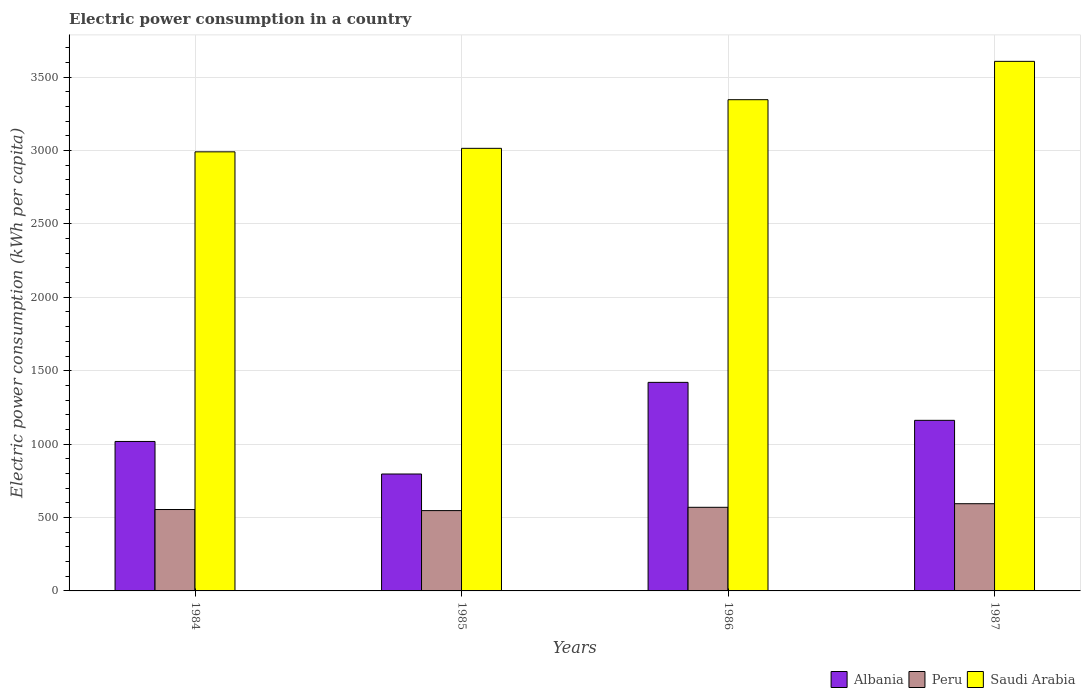How many different coloured bars are there?
Offer a very short reply. 3. Are the number of bars per tick equal to the number of legend labels?
Your response must be concise. Yes. Are the number of bars on each tick of the X-axis equal?
Give a very brief answer. Yes. How many bars are there on the 1st tick from the left?
Provide a succinct answer. 3. What is the label of the 3rd group of bars from the left?
Give a very brief answer. 1986. What is the electric power consumption in in Albania in 1987?
Ensure brevity in your answer.  1161.95. Across all years, what is the maximum electric power consumption in in Saudi Arabia?
Your answer should be compact. 3607.28. Across all years, what is the minimum electric power consumption in in Albania?
Give a very brief answer. 796.35. In which year was the electric power consumption in in Albania maximum?
Your answer should be very brief. 1986. What is the total electric power consumption in in Peru in the graph?
Your answer should be very brief. 2265.2. What is the difference between the electric power consumption in in Albania in 1985 and that in 1987?
Provide a short and direct response. -365.6. What is the difference between the electric power consumption in in Albania in 1986 and the electric power consumption in in Saudi Arabia in 1985?
Provide a succinct answer. -1594.14. What is the average electric power consumption in in Saudi Arabia per year?
Your answer should be compact. 3239.76. In the year 1986, what is the difference between the electric power consumption in in Albania and electric power consumption in in Peru?
Keep it short and to the point. 851.01. What is the ratio of the electric power consumption in in Peru in 1984 to that in 1985?
Keep it short and to the point. 1.01. Is the electric power consumption in in Peru in 1984 less than that in 1985?
Give a very brief answer. No. What is the difference between the highest and the second highest electric power consumption in in Albania?
Your response must be concise. 258.66. What is the difference between the highest and the lowest electric power consumption in in Peru?
Your response must be concise. 46.98. What does the 2nd bar from the left in 1984 represents?
Offer a terse response. Peru. What does the 1st bar from the right in 1986 represents?
Offer a very short reply. Saudi Arabia. Are all the bars in the graph horizontal?
Ensure brevity in your answer.  No. Are the values on the major ticks of Y-axis written in scientific E-notation?
Offer a terse response. No. Does the graph contain grids?
Offer a terse response. Yes. Where does the legend appear in the graph?
Your answer should be compact. Bottom right. What is the title of the graph?
Offer a very short reply. Electric power consumption in a country. Does "Monaco" appear as one of the legend labels in the graph?
Give a very brief answer. No. What is the label or title of the X-axis?
Provide a succinct answer. Years. What is the label or title of the Y-axis?
Provide a succinct answer. Electric power consumption (kWh per capita). What is the Electric power consumption (kWh per capita) in Albania in 1984?
Provide a succinct answer. 1018.1. What is the Electric power consumption (kWh per capita) of Peru in 1984?
Provide a short and direct response. 554.41. What is the Electric power consumption (kWh per capita) in Saudi Arabia in 1984?
Provide a short and direct response. 2990.91. What is the Electric power consumption (kWh per capita) in Albania in 1985?
Keep it short and to the point. 796.35. What is the Electric power consumption (kWh per capita) of Peru in 1985?
Ensure brevity in your answer.  547.1. What is the Electric power consumption (kWh per capita) of Saudi Arabia in 1985?
Ensure brevity in your answer.  3014.76. What is the Electric power consumption (kWh per capita) in Albania in 1986?
Your answer should be compact. 1420.61. What is the Electric power consumption (kWh per capita) of Peru in 1986?
Give a very brief answer. 569.61. What is the Electric power consumption (kWh per capita) of Saudi Arabia in 1986?
Offer a terse response. 3346.11. What is the Electric power consumption (kWh per capita) in Albania in 1987?
Give a very brief answer. 1161.95. What is the Electric power consumption (kWh per capita) of Peru in 1987?
Keep it short and to the point. 594.08. What is the Electric power consumption (kWh per capita) in Saudi Arabia in 1987?
Ensure brevity in your answer.  3607.28. Across all years, what is the maximum Electric power consumption (kWh per capita) of Albania?
Give a very brief answer. 1420.61. Across all years, what is the maximum Electric power consumption (kWh per capita) of Peru?
Make the answer very short. 594.08. Across all years, what is the maximum Electric power consumption (kWh per capita) in Saudi Arabia?
Give a very brief answer. 3607.28. Across all years, what is the minimum Electric power consumption (kWh per capita) in Albania?
Ensure brevity in your answer.  796.35. Across all years, what is the minimum Electric power consumption (kWh per capita) in Peru?
Your answer should be very brief. 547.1. Across all years, what is the minimum Electric power consumption (kWh per capita) in Saudi Arabia?
Make the answer very short. 2990.91. What is the total Electric power consumption (kWh per capita) in Albania in the graph?
Make the answer very short. 4397.02. What is the total Electric power consumption (kWh per capita) of Peru in the graph?
Offer a terse response. 2265.2. What is the total Electric power consumption (kWh per capita) in Saudi Arabia in the graph?
Keep it short and to the point. 1.30e+04. What is the difference between the Electric power consumption (kWh per capita) in Albania in 1984 and that in 1985?
Offer a terse response. 221.75. What is the difference between the Electric power consumption (kWh per capita) in Peru in 1984 and that in 1985?
Offer a terse response. 7.31. What is the difference between the Electric power consumption (kWh per capita) of Saudi Arabia in 1984 and that in 1985?
Keep it short and to the point. -23.85. What is the difference between the Electric power consumption (kWh per capita) in Albania in 1984 and that in 1986?
Your answer should be very brief. -402.51. What is the difference between the Electric power consumption (kWh per capita) in Peru in 1984 and that in 1986?
Offer a terse response. -15.2. What is the difference between the Electric power consumption (kWh per capita) in Saudi Arabia in 1984 and that in 1986?
Offer a terse response. -355.21. What is the difference between the Electric power consumption (kWh per capita) of Albania in 1984 and that in 1987?
Ensure brevity in your answer.  -143.85. What is the difference between the Electric power consumption (kWh per capita) of Peru in 1984 and that in 1987?
Your answer should be very brief. -39.67. What is the difference between the Electric power consumption (kWh per capita) in Saudi Arabia in 1984 and that in 1987?
Offer a very short reply. -616.37. What is the difference between the Electric power consumption (kWh per capita) in Albania in 1985 and that in 1986?
Provide a short and direct response. -624.26. What is the difference between the Electric power consumption (kWh per capita) in Peru in 1985 and that in 1986?
Provide a succinct answer. -22.51. What is the difference between the Electric power consumption (kWh per capita) in Saudi Arabia in 1985 and that in 1986?
Ensure brevity in your answer.  -331.36. What is the difference between the Electric power consumption (kWh per capita) of Albania in 1985 and that in 1987?
Provide a succinct answer. -365.6. What is the difference between the Electric power consumption (kWh per capita) of Peru in 1985 and that in 1987?
Ensure brevity in your answer.  -46.98. What is the difference between the Electric power consumption (kWh per capita) in Saudi Arabia in 1985 and that in 1987?
Keep it short and to the point. -592.52. What is the difference between the Electric power consumption (kWh per capita) of Albania in 1986 and that in 1987?
Offer a terse response. 258.66. What is the difference between the Electric power consumption (kWh per capita) of Peru in 1986 and that in 1987?
Your answer should be compact. -24.48. What is the difference between the Electric power consumption (kWh per capita) of Saudi Arabia in 1986 and that in 1987?
Offer a terse response. -261.16. What is the difference between the Electric power consumption (kWh per capita) of Albania in 1984 and the Electric power consumption (kWh per capita) of Peru in 1985?
Give a very brief answer. 471. What is the difference between the Electric power consumption (kWh per capita) of Albania in 1984 and the Electric power consumption (kWh per capita) of Saudi Arabia in 1985?
Your answer should be very brief. -1996.65. What is the difference between the Electric power consumption (kWh per capita) of Peru in 1984 and the Electric power consumption (kWh per capita) of Saudi Arabia in 1985?
Provide a short and direct response. -2460.34. What is the difference between the Electric power consumption (kWh per capita) of Albania in 1984 and the Electric power consumption (kWh per capita) of Peru in 1986?
Your answer should be very brief. 448.49. What is the difference between the Electric power consumption (kWh per capita) in Albania in 1984 and the Electric power consumption (kWh per capita) in Saudi Arabia in 1986?
Offer a very short reply. -2328.01. What is the difference between the Electric power consumption (kWh per capita) of Peru in 1984 and the Electric power consumption (kWh per capita) of Saudi Arabia in 1986?
Offer a very short reply. -2791.7. What is the difference between the Electric power consumption (kWh per capita) in Albania in 1984 and the Electric power consumption (kWh per capita) in Peru in 1987?
Make the answer very short. 424.02. What is the difference between the Electric power consumption (kWh per capita) in Albania in 1984 and the Electric power consumption (kWh per capita) in Saudi Arabia in 1987?
Your answer should be compact. -2589.17. What is the difference between the Electric power consumption (kWh per capita) of Peru in 1984 and the Electric power consumption (kWh per capita) of Saudi Arabia in 1987?
Give a very brief answer. -3052.86. What is the difference between the Electric power consumption (kWh per capita) in Albania in 1985 and the Electric power consumption (kWh per capita) in Peru in 1986?
Offer a very short reply. 226.75. What is the difference between the Electric power consumption (kWh per capita) in Albania in 1985 and the Electric power consumption (kWh per capita) in Saudi Arabia in 1986?
Offer a terse response. -2549.76. What is the difference between the Electric power consumption (kWh per capita) of Peru in 1985 and the Electric power consumption (kWh per capita) of Saudi Arabia in 1986?
Give a very brief answer. -2799.01. What is the difference between the Electric power consumption (kWh per capita) in Albania in 1985 and the Electric power consumption (kWh per capita) in Peru in 1987?
Provide a short and direct response. 202.27. What is the difference between the Electric power consumption (kWh per capita) of Albania in 1985 and the Electric power consumption (kWh per capita) of Saudi Arabia in 1987?
Give a very brief answer. -2810.92. What is the difference between the Electric power consumption (kWh per capita) in Peru in 1985 and the Electric power consumption (kWh per capita) in Saudi Arabia in 1987?
Provide a short and direct response. -3060.18. What is the difference between the Electric power consumption (kWh per capita) of Albania in 1986 and the Electric power consumption (kWh per capita) of Peru in 1987?
Ensure brevity in your answer.  826.53. What is the difference between the Electric power consumption (kWh per capita) of Albania in 1986 and the Electric power consumption (kWh per capita) of Saudi Arabia in 1987?
Your answer should be compact. -2186.66. What is the difference between the Electric power consumption (kWh per capita) of Peru in 1986 and the Electric power consumption (kWh per capita) of Saudi Arabia in 1987?
Keep it short and to the point. -3037.67. What is the average Electric power consumption (kWh per capita) in Albania per year?
Your response must be concise. 1099.26. What is the average Electric power consumption (kWh per capita) in Peru per year?
Provide a short and direct response. 566.3. What is the average Electric power consumption (kWh per capita) in Saudi Arabia per year?
Your response must be concise. 3239.76. In the year 1984, what is the difference between the Electric power consumption (kWh per capita) of Albania and Electric power consumption (kWh per capita) of Peru?
Keep it short and to the point. 463.69. In the year 1984, what is the difference between the Electric power consumption (kWh per capita) of Albania and Electric power consumption (kWh per capita) of Saudi Arabia?
Your answer should be very brief. -1972.81. In the year 1984, what is the difference between the Electric power consumption (kWh per capita) of Peru and Electric power consumption (kWh per capita) of Saudi Arabia?
Your answer should be very brief. -2436.5. In the year 1985, what is the difference between the Electric power consumption (kWh per capita) in Albania and Electric power consumption (kWh per capita) in Peru?
Provide a succinct answer. 249.26. In the year 1985, what is the difference between the Electric power consumption (kWh per capita) of Albania and Electric power consumption (kWh per capita) of Saudi Arabia?
Provide a short and direct response. -2218.4. In the year 1985, what is the difference between the Electric power consumption (kWh per capita) in Peru and Electric power consumption (kWh per capita) in Saudi Arabia?
Provide a short and direct response. -2467.66. In the year 1986, what is the difference between the Electric power consumption (kWh per capita) in Albania and Electric power consumption (kWh per capita) in Peru?
Your answer should be very brief. 851.01. In the year 1986, what is the difference between the Electric power consumption (kWh per capita) of Albania and Electric power consumption (kWh per capita) of Saudi Arabia?
Your answer should be compact. -1925.5. In the year 1986, what is the difference between the Electric power consumption (kWh per capita) of Peru and Electric power consumption (kWh per capita) of Saudi Arabia?
Give a very brief answer. -2776.5. In the year 1987, what is the difference between the Electric power consumption (kWh per capita) of Albania and Electric power consumption (kWh per capita) of Peru?
Your answer should be compact. 567.87. In the year 1987, what is the difference between the Electric power consumption (kWh per capita) of Albania and Electric power consumption (kWh per capita) of Saudi Arabia?
Provide a succinct answer. -2445.32. In the year 1987, what is the difference between the Electric power consumption (kWh per capita) in Peru and Electric power consumption (kWh per capita) in Saudi Arabia?
Offer a very short reply. -3013.19. What is the ratio of the Electric power consumption (kWh per capita) of Albania in 1984 to that in 1985?
Make the answer very short. 1.28. What is the ratio of the Electric power consumption (kWh per capita) in Peru in 1984 to that in 1985?
Your answer should be compact. 1.01. What is the ratio of the Electric power consumption (kWh per capita) in Saudi Arabia in 1984 to that in 1985?
Offer a very short reply. 0.99. What is the ratio of the Electric power consumption (kWh per capita) in Albania in 1984 to that in 1986?
Offer a very short reply. 0.72. What is the ratio of the Electric power consumption (kWh per capita) of Peru in 1984 to that in 1986?
Offer a very short reply. 0.97. What is the ratio of the Electric power consumption (kWh per capita) in Saudi Arabia in 1984 to that in 1986?
Offer a terse response. 0.89. What is the ratio of the Electric power consumption (kWh per capita) of Albania in 1984 to that in 1987?
Your answer should be compact. 0.88. What is the ratio of the Electric power consumption (kWh per capita) of Peru in 1984 to that in 1987?
Your response must be concise. 0.93. What is the ratio of the Electric power consumption (kWh per capita) of Saudi Arabia in 1984 to that in 1987?
Keep it short and to the point. 0.83. What is the ratio of the Electric power consumption (kWh per capita) in Albania in 1985 to that in 1986?
Your answer should be very brief. 0.56. What is the ratio of the Electric power consumption (kWh per capita) in Peru in 1985 to that in 1986?
Provide a succinct answer. 0.96. What is the ratio of the Electric power consumption (kWh per capita) in Saudi Arabia in 1985 to that in 1986?
Your response must be concise. 0.9. What is the ratio of the Electric power consumption (kWh per capita) in Albania in 1985 to that in 1987?
Keep it short and to the point. 0.69. What is the ratio of the Electric power consumption (kWh per capita) of Peru in 1985 to that in 1987?
Provide a succinct answer. 0.92. What is the ratio of the Electric power consumption (kWh per capita) in Saudi Arabia in 1985 to that in 1987?
Offer a terse response. 0.84. What is the ratio of the Electric power consumption (kWh per capita) of Albania in 1986 to that in 1987?
Your response must be concise. 1.22. What is the ratio of the Electric power consumption (kWh per capita) of Peru in 1986 to that in 1987?
Keep it short and to the point. 0.96. What is the ratio of the Electric power consumption (kWh per capita) in Saudi Arabia in 1986 to that in 1987?
Your answer should be very brief. 0.93. What is the difference between the highest and the second highest Electric power consumption (kWh per capita) of Albania?
Offer a terse response. 258.66. What is the difference between the highest and the second highest Electric power consumption (kWh per capita) in Peru?
Keep it short and to the point. 24.48. What is the difference between the highest and the second highest Electric power consumption (kWh per capita) of Saudi Arabia?
Keep it short and to the point. 261.16. What is the difference between the highest and the lowest Electric power consumption (kWh per capita) in Albania?
Your answer should be compact. 624.26. What is the difference between the highest and the lowest Electric power consumption (kWh per capita) in Peru?
Your answer should be very brief. 46.98. What is the difference between the highest and the lowest Electric power consumption (kWh per capita) of Saudi Arabia?
Provide a short and direct response. 616.37. 